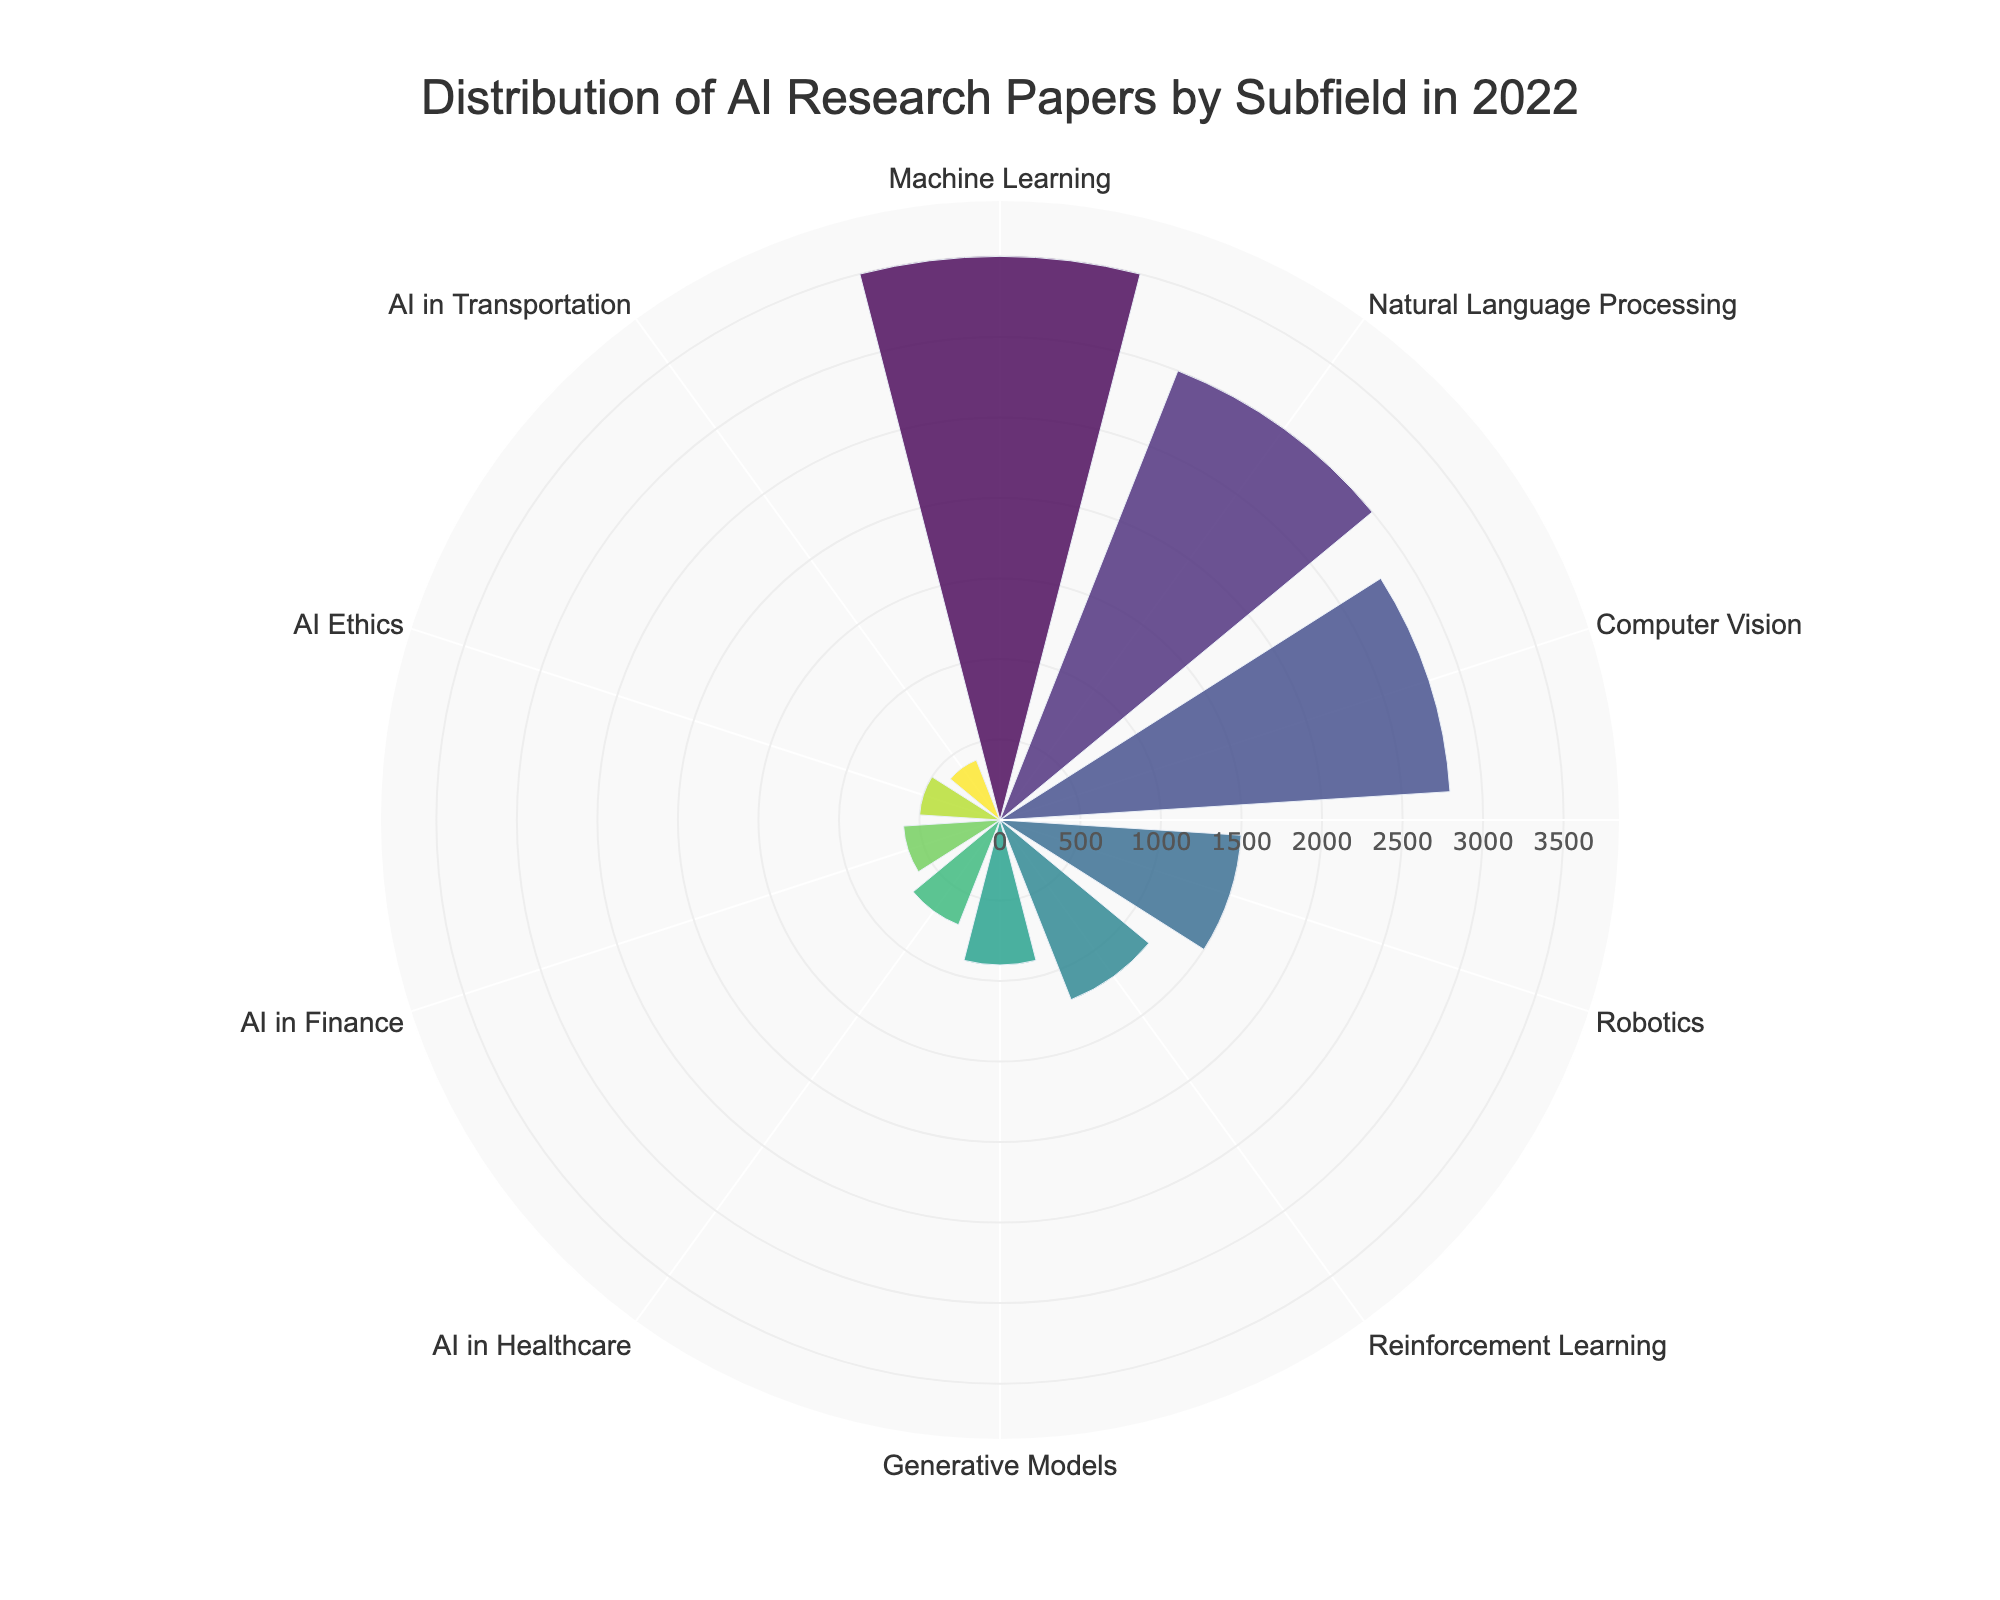What is the subfield with the highest number of research papers? By observing the radial length in the polar area chart, Machine Learning has the longest bar indicating the highest count of research papers.
Answer: Machine Learning How many research papers are there in the AI Ethics subfield? The bar representing AI Ethics has the label showing it has 500 research papers.
Answer: 500 What is the combined number of research papers in Natural Language Processing and Computer Vision? Natural Language Processing has 3000 papers, and Computer Vision has 2800 papers. Adding these together results in 3000 + 2800 = 5800.
Answer: 5800 Which subfield has fewer research papers: AI in Healthcare or AI in Finance? The bar for AI in Healthcare is slightly longer than the bar for AI in Finance, indicating AI in Finance has fewer papers.
Answer: AI in Finance What is the average number of research papers across all subfields? Summing the counts of all subfields: 3500 + 3000 + 2800 + 1500 + 1200 + 900 + 500 + 700 + 600 + 400 = 14900. There are 10 subfields, so the average is 14900 / 10 = 1490.
Answer: 1490 Which subfield has the shortest bar in the figure? The shortest bar represents the subfield with the least research papers. This is AI in Transportation with 400 papers.
Answer: AI in Transportation Is the number of research papers in Robotics greater than in Reinforcement Learning? By comparing the lengths of the bars, the bar for Robotics is longer than the bar for Reinforcement Learning, indicating a higher count.
Answer: Yes How does the count of research papers in Generative Models compare to AI in Healthcare? The bar for Generative Models is slightly shorter than the bar for AI in Healthcare, so there are fewer research papers in Generative Models.
Answer: Fewer What is the total number of research papers in the subfields with fewer than 1000 papers each? The subfields with fewer than 1000 papers are: Generative Models with 900, AI Ethics with 500, AI in Healthcare with 700, AI in Finance with 600, and AI in Transportation with 400. Summing these: 900 + 500 + 700 + 600 + 400 = 3100.
Answer: 3100 What percentage of the total research papers does the Natural Language Processing subfield represent? Total number of research papers is 14900. Natural Language Processing has 3000 papers. The percentage is (3000 / 14900) * 100 ≈ 20.13%.
Answer: 20.13% 